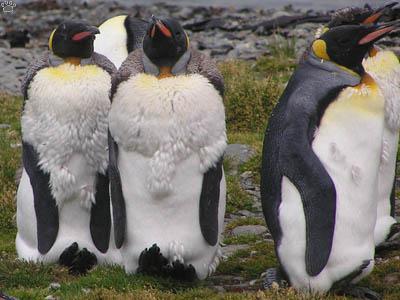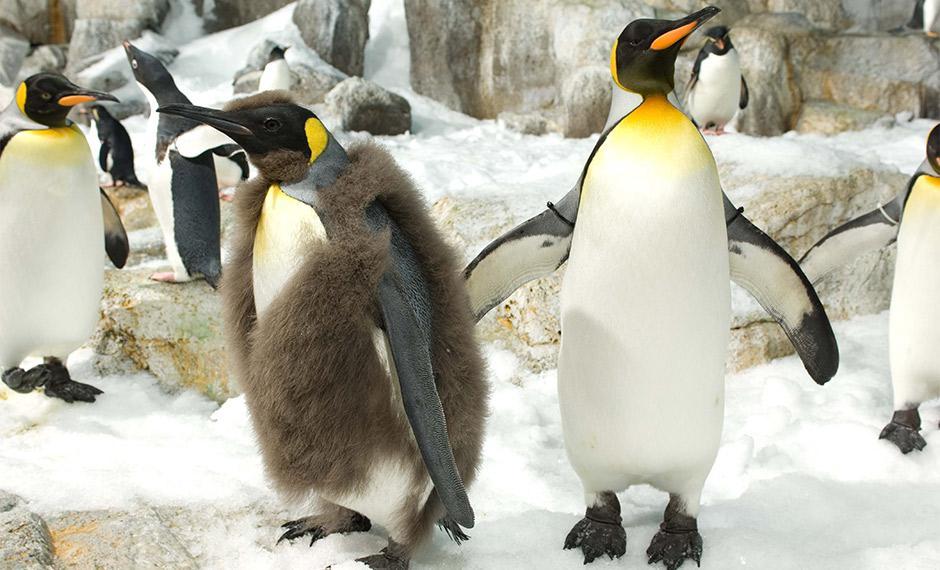The first image is the image on the left, the second image is the image on the right. For the images shown, is this caption "The right image shows a very young fuzzy penguin with some white on its face." true? Answer yes or no. No. 